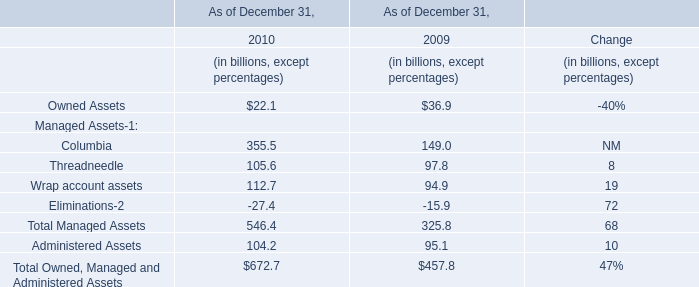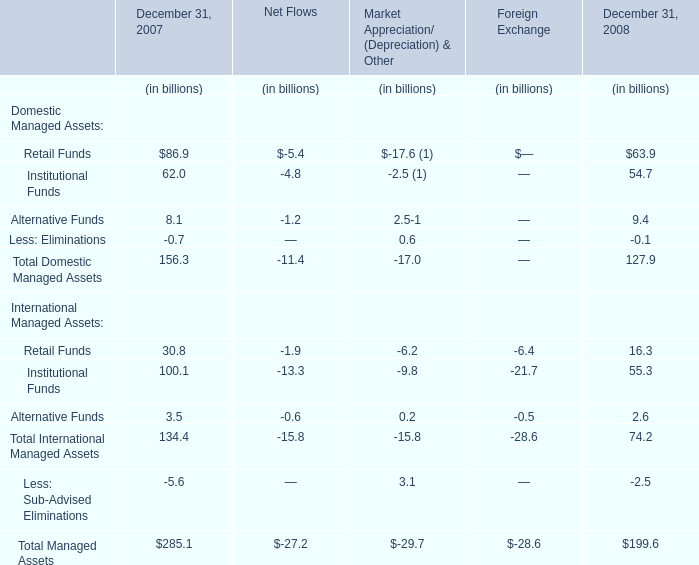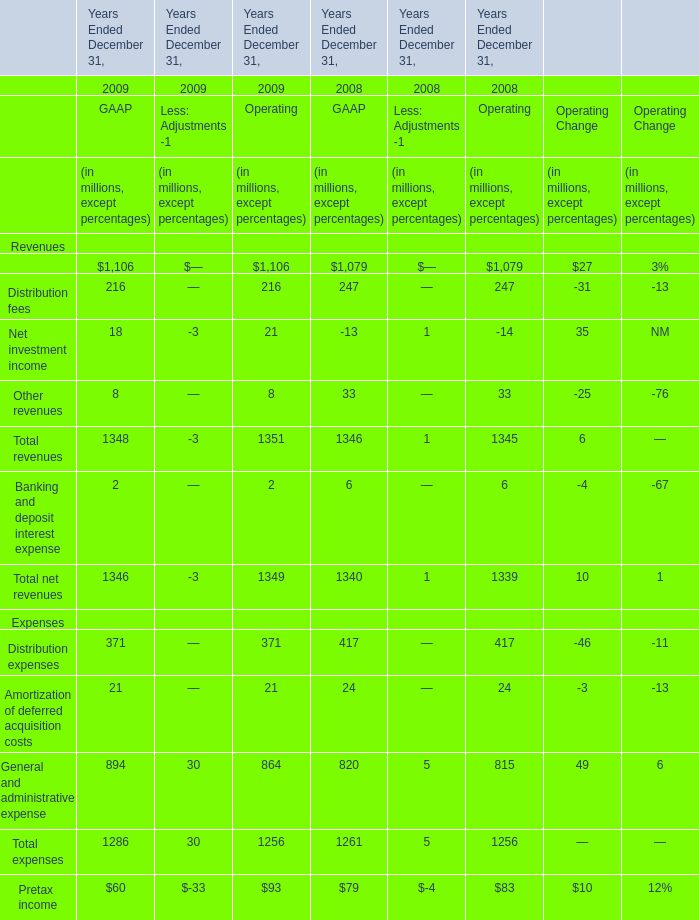What's the total amount of Total revenues in the range of 0 and 1500 in 2009? (in million) 
Computations: (1348 + 1351)
Answer: 2699.0. 